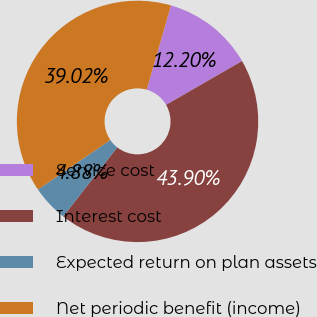Convert chart. <chart><loc_0><loc_0><loc_500><loc_500><pie_chart><fcel>Service cost<fcel>Interest cost<fcel>Expected return on plan assets<fcel>Net periodic benefit (income)<nl><fcel>12.2%<fcel>43.9%<fcel>4.88%<fcel>39.02%<nl></chart> 